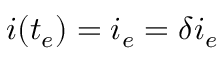<formula> <loc_0><loc_0><loc_500><loc_500>i ( t _ { e } ) = i _ { e } = \delta i _ { e }</formula> 